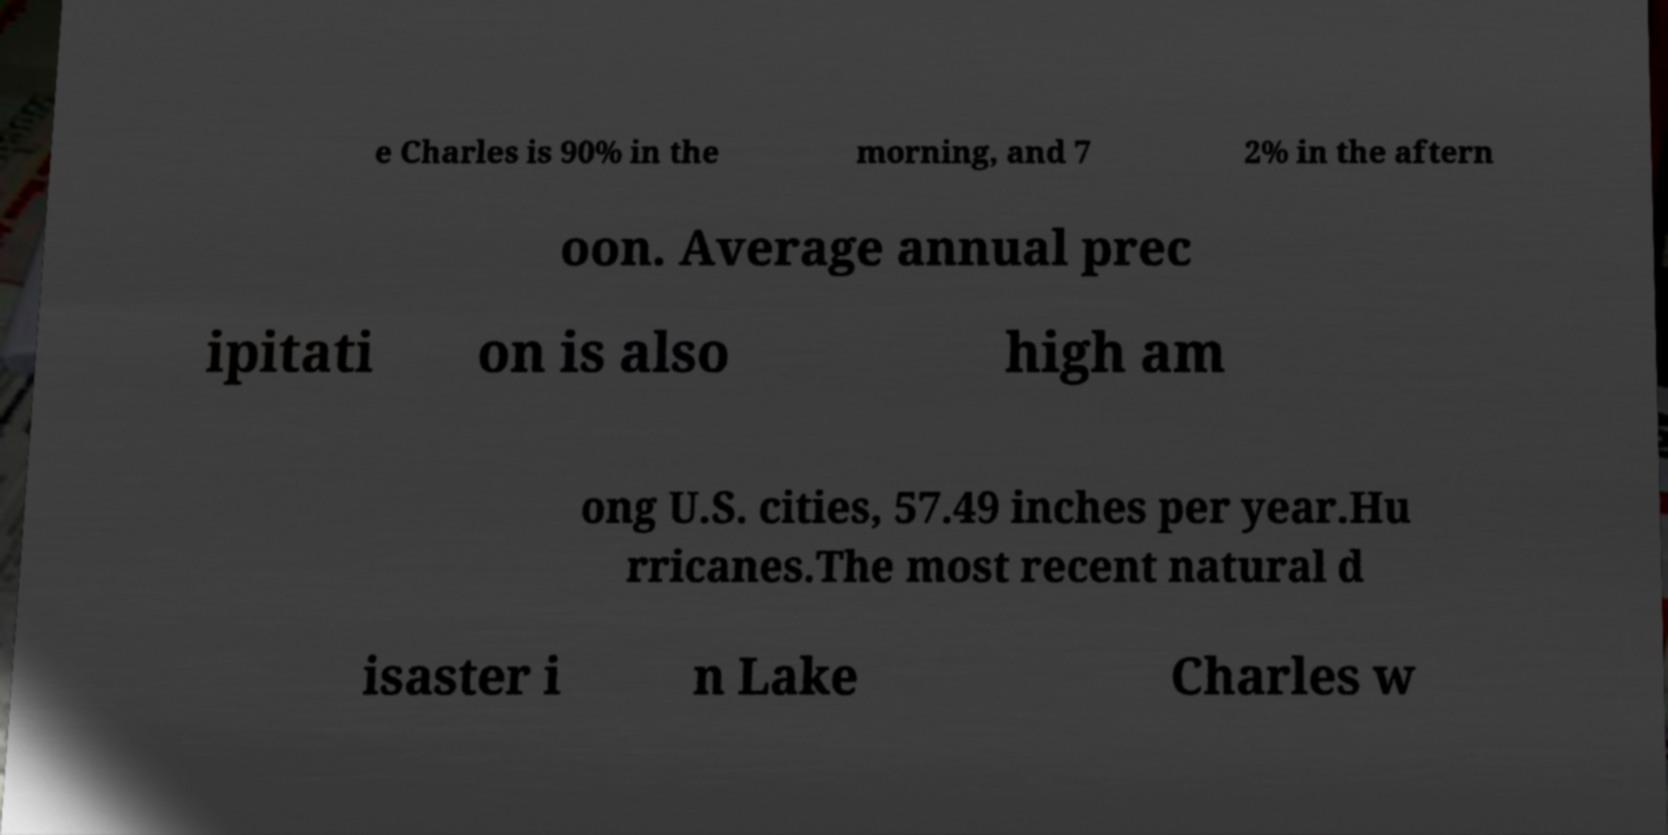I need the written content from this picture converted into text. Can you do that? e Charles is 90% in the morning, and 7 2% in the aftern oon. Average annual prec ipitati on is also high am ong U.S. cities, 57.49 inches per year.Hu rricanes.The most recent natural d isaster i n Lake Charles w 